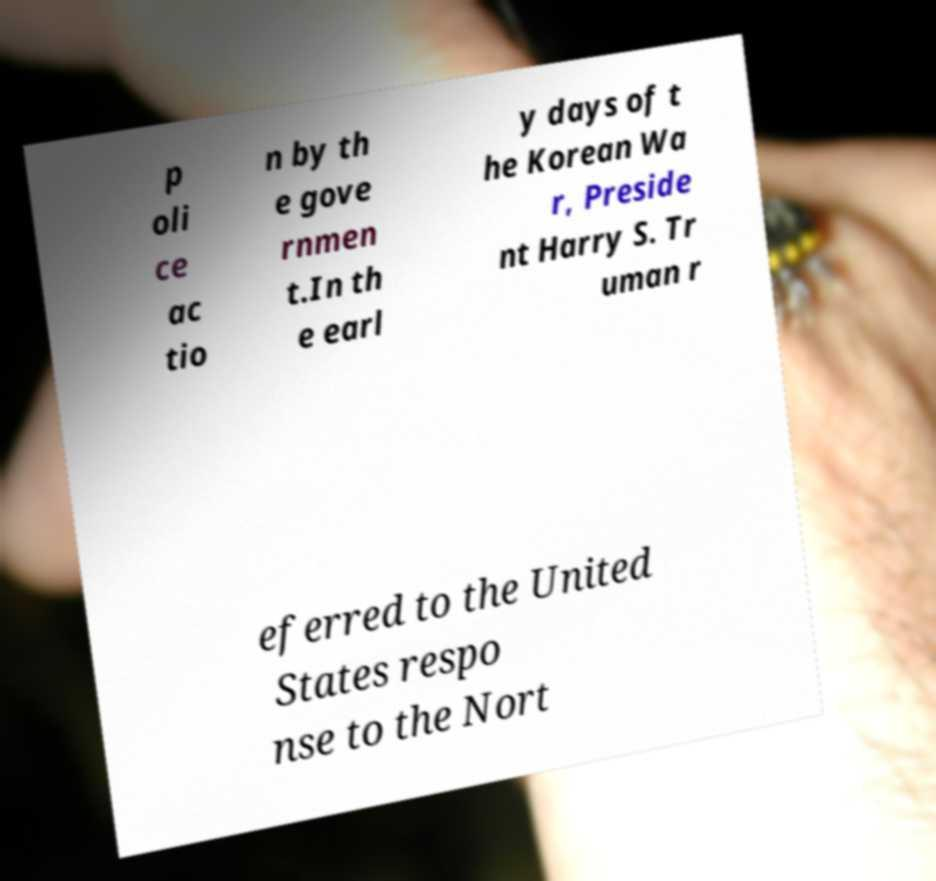What messages or text are displayed in this image? I need them in a readable, typed format. p oli ce ac tio n by th e gove rnmen t.In th e earl y days of t he Korean Wa r, Preside nt Harry S. Tr uman r eferred to the United States respo nse to the Nort 